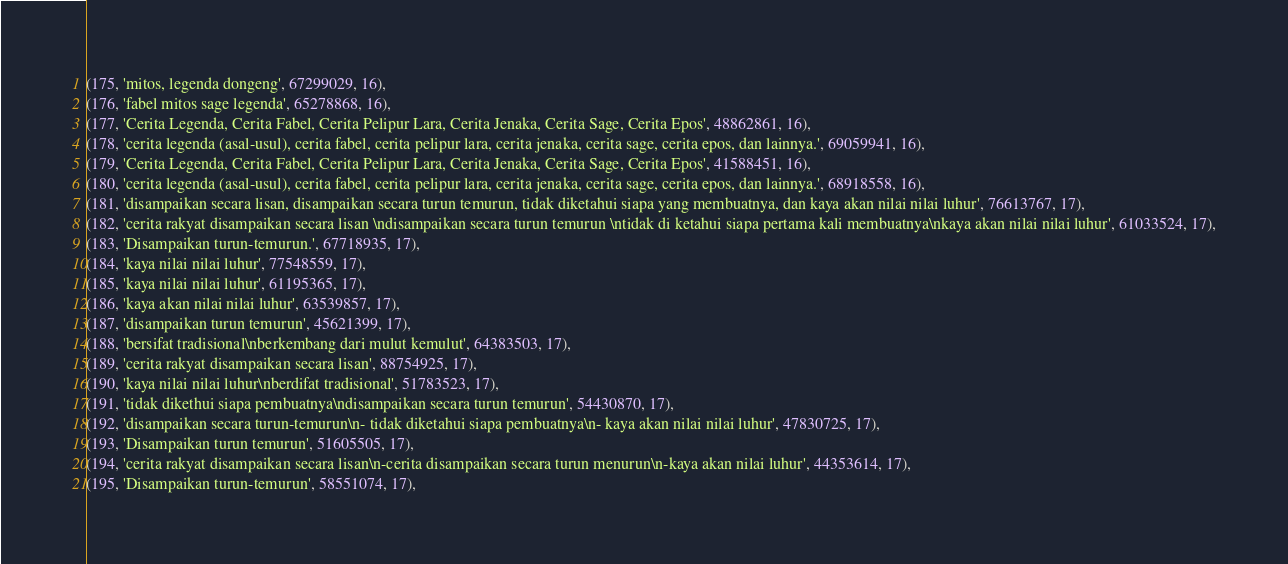Convert code to text. <code><loc_0><loc_0><loc_500><loc_500><_SQL_>(175, 'mitos, legenda dongeng', 67299029, 16),
(176, 'fabel mitos sage legenda', 65278868, 16),
(177, 'Cerita Legenda, Cerita Fabel, Cerita Pelipur Lara, Cerita Jenaka, Cerita Sage, Cerita Epos', 48862861, 16),
(178, 'cerita legenda (asal-usul), cerita fabel, cerita pelipur lara, cerita jenaka, cerita sage, cerita epos, dan lainnya.', 69059941, 16),
(179, 'Cerita Legenda, Cerita Fabel, Cerita Pelipur Lara, Cerita Jenaka, Cerita Sage, Cerita Epos', 41588451, 16),
(180, 'cerita legenda (asal-usul), cerita fabel, cerita pelipur lara, cerita jenaka, cerita sage, cerita epos, dan lainnya.', 68918558, 16),
(181, 'disampaikan secara lisan, disampaikan secara turun temurun, tidak diketahui siapa yang membuatnya, dan kaya akan nilai nilai luhur', 76613767, 17),
(182, 'cerita rakyat disampaikan secara lisan \ndisampaikan secara turun temurun \ntidak di ketahui siapa pertama kali membuatnya\nkaya akan nilai nilai luhur', 61033524, 17),
(183, 'Disampaikan turun-temurun.', 67718935, 17),
(184, 'kaya nilai nilai luhur', 77548559, 17),
(185, 'kaya nilai nilai luhur', 61195365, 17),
(186, 'kaya akan nilai nilai luhur', 63539857, 17),
(187, 'disampaikan turun temurun', 45621399, 17),
(188, 'bersifat tradisional\nberkembang dari mulut kemulut', 64383503, 17),
(189, 'cerita rakyat disampaikan secara lisan', 88754925, 17),
(190, 'kaya nilai nilai luhur\nberdifat tradisional', 51783523, 17),
(191, 'tidak dikethui siapa pembuatnya\ndisampaikan secara turun temurun', 54430870, 17),
(192, 'disampaikan secara turun-temurun\n- tidak diketahui siapa pembuatnya\n- kaya akan nilai nilai luhur', 47830725, 17),
(193, 'Disampaikan turun temurun', 51605505, 17),
(194, 'cerita rakyat disampaikan secara lisan\n-cerita disampaikan secara turun menurun\n-kaya akan nilai luhur', 44353614, 17),
(195, 'Disampaikan turun-temurun', 58551074, 17),</code> 